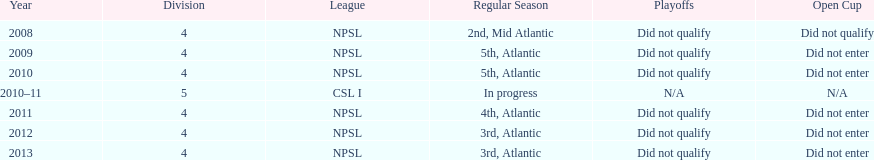What is the number of 3rd place finishes for npsl? 2. 